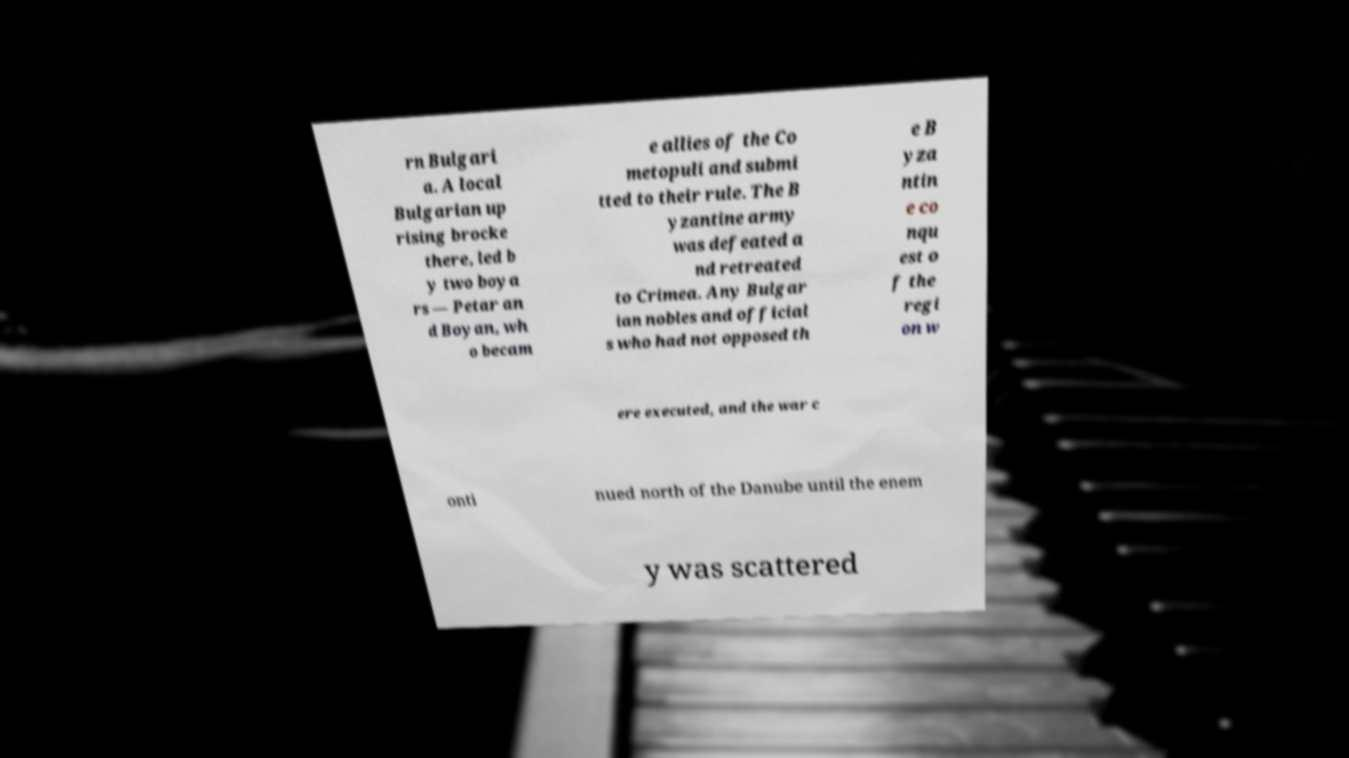There's text embedded in this image that I need extracted. Can you transcribe it verbatim? rn Bulgari a. A local Bulgarian up rising brocke there, led b y two boya rs — Petar an d Boyan, wh o becam e allies of the Co metopuli and submi tted to their rule. The B yzantine army was defeated a nd retreated to Crimea. Any Bulgar ian nobles and official s who had not opposed th e B yza ntin e co nqu est o f the regi on w ere executed, and the war c onti nued north of the Danube until the enem y was scattered 